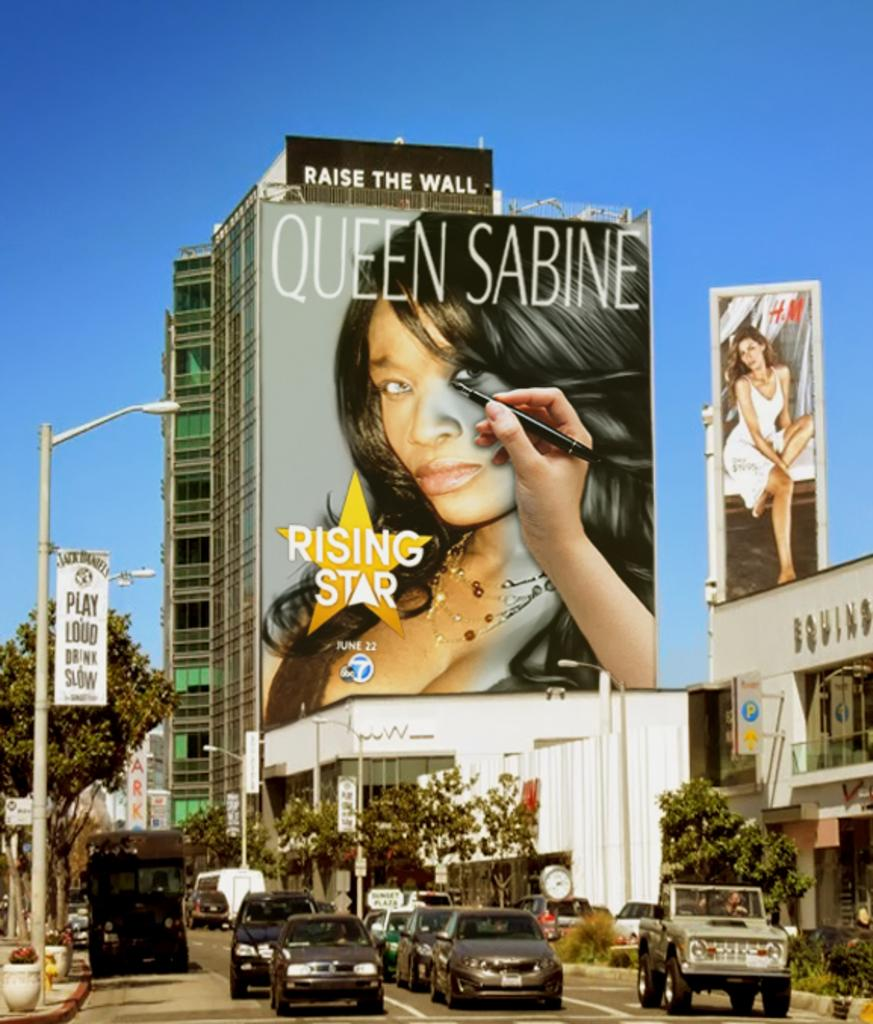<image>
Offer a succinct explanation of the picture presented. A downtown center with traffic and billboard promoting Queen Sabine. 